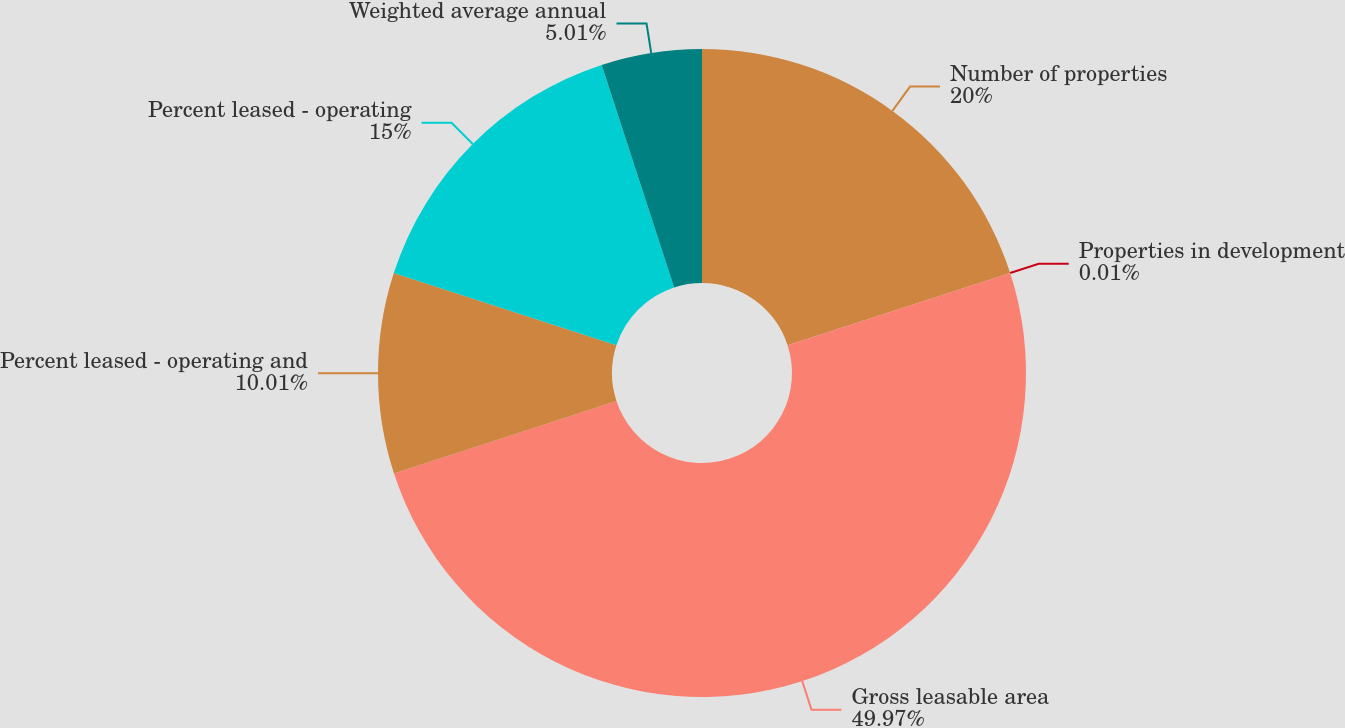Convert chart to OTSL. <chart><loc_0><loc_0><loc_500><loc_500><pie_chart><fcel>Number of properties<fcel>Properties in development<fcel>Gross leasable area<fcel>Percent leased - operating and<fcel>Percent leased - operating<fcel>Weighted average annual<nl><fcel>20.0%<fcel>0.01%<fcel>49.97%<fcel>10.01%<fcel>15.0%<fcel>5.01%<nl></chart> 